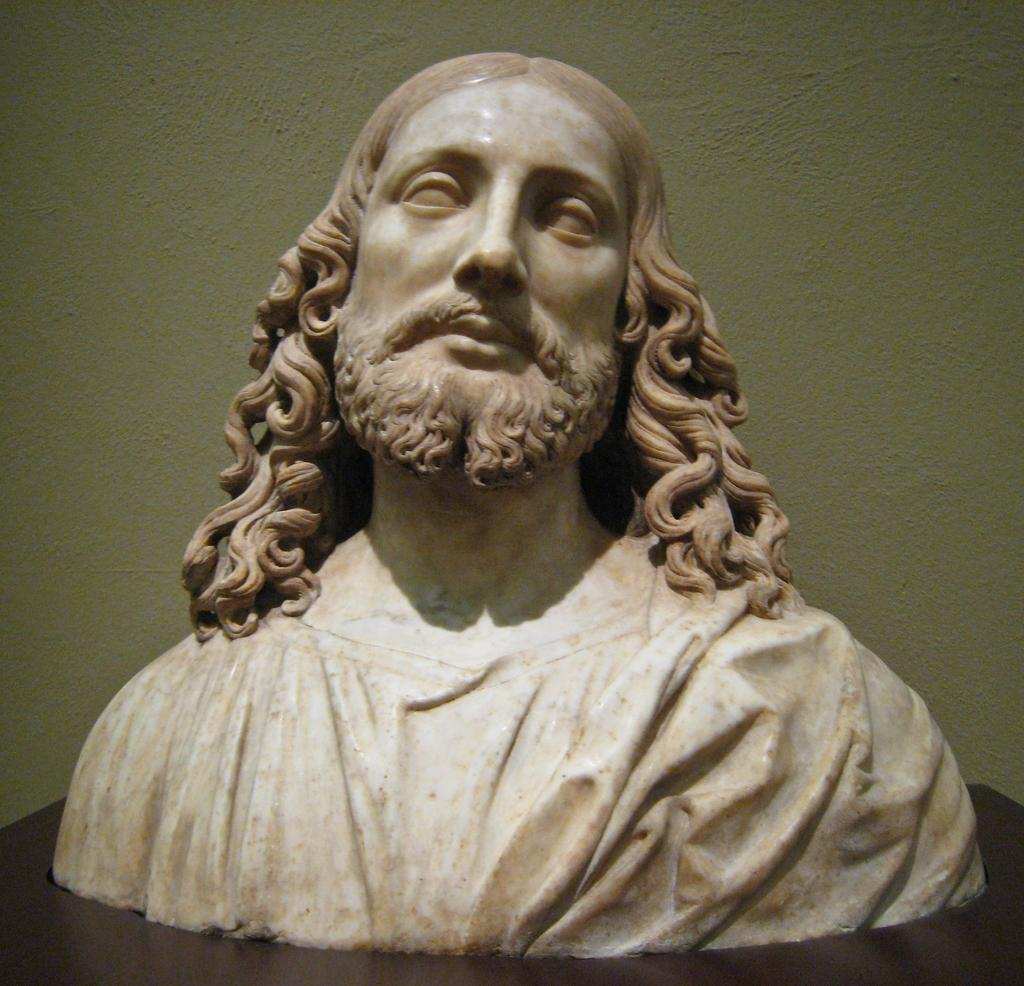What is the main subject in the center of the image? There is a statue in the center of the image. What can be seen in the background of the image? There is a well in the background of the image. What type of lipstick is the statue wearing in the image? The statue does not have a lipstick or any facial features, as it is a non-human subject. 